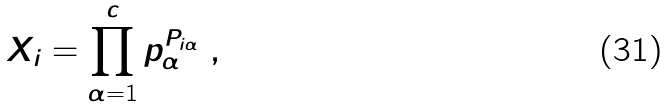Convert formula to latex. <formula><loc_0><loc_0><loc_500><loc_500>X _ { i } = \prod _ { \alpha = 1 } ^ { c } p _ { \alpha } ^ { P _ { i \alpha } } \ ,</formula> 